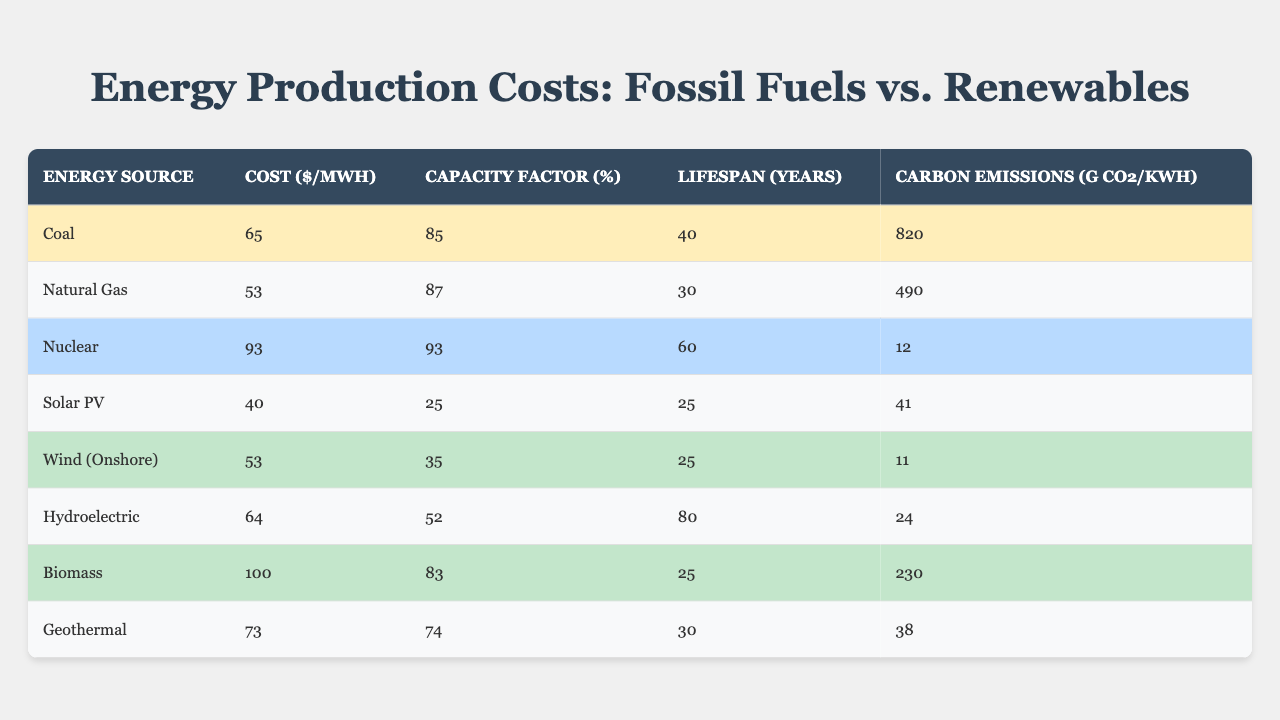What is the cost per MWh for coal? The table lists coal's cost in the "Cost ($/MWh)" column, which shows a value of 65.
Answer: 65 Which energy source has the lowest carbon emissions? By comparing the "Carbon Emissions (g CO2/kWh)" values, solar PV has the lowest at 41.
Answer: Solar PV What is the capacity factor of natural gas? The "Capacity Factor (%)" column shows that natural gas has a capacity factor of 87%.
Answer: 87% What is the average cost of fossil fuels? The average can be found by adding coal (65) and natural gas (53), which totals 118. Dividing by 2 gives an average of 59.
Answer: 59 Which renewable source has the longest lifespan? The "Lifespan (Years)" column indicates that hydroelectric has the longest lifespan at 80 years compared to other renewables.
Answer: Hydroelectric Is the capacity factor for wind energy greater than for solar energy? The capacity factor for wind (35%) is greater than solar (25%), confirming the statement is true.
Answer: Yes What is the difference in carbon emissions between coal and natural gas? Coal's emissions are 820 g CO2/kWh, and natural gas's are 490 g CO2/kWh. Subtracting gives 330 g CO2/kWh.
Answer: 330 Visualizing the data, which energy source has the highest cost and the lowest carbon emissions? By examining the "Cost ($/MWh)" and "Carbon Emissions (g CO2/kWh)" columns, biomass has the highest cost at 100, and solar has the lowest emissions at 41.
Answer: Biomass (cost), Solar PV (emissions) If we consider only renewables, which one has the lowest cost per MWh? By comparing the costs of the renewable sources, solar PV has the lowest cost at 40 $/MWh.
Answer: Solar PV What energy source has the highest carbon emissions, and what is that value? The table reveals that coal has the highest carbon emissions at 820 g CO2/kWh.
Answer: Coal, 820 